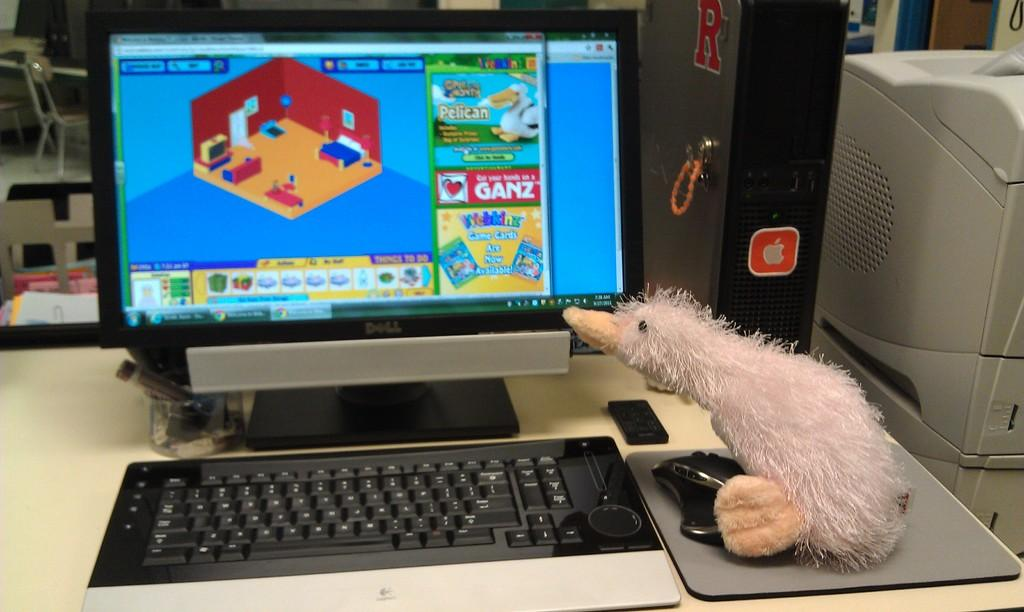<image>
Render a clear and concise summary of the photo. A stuffed duck examines a computer monitor advertising Webkinz game cards. 